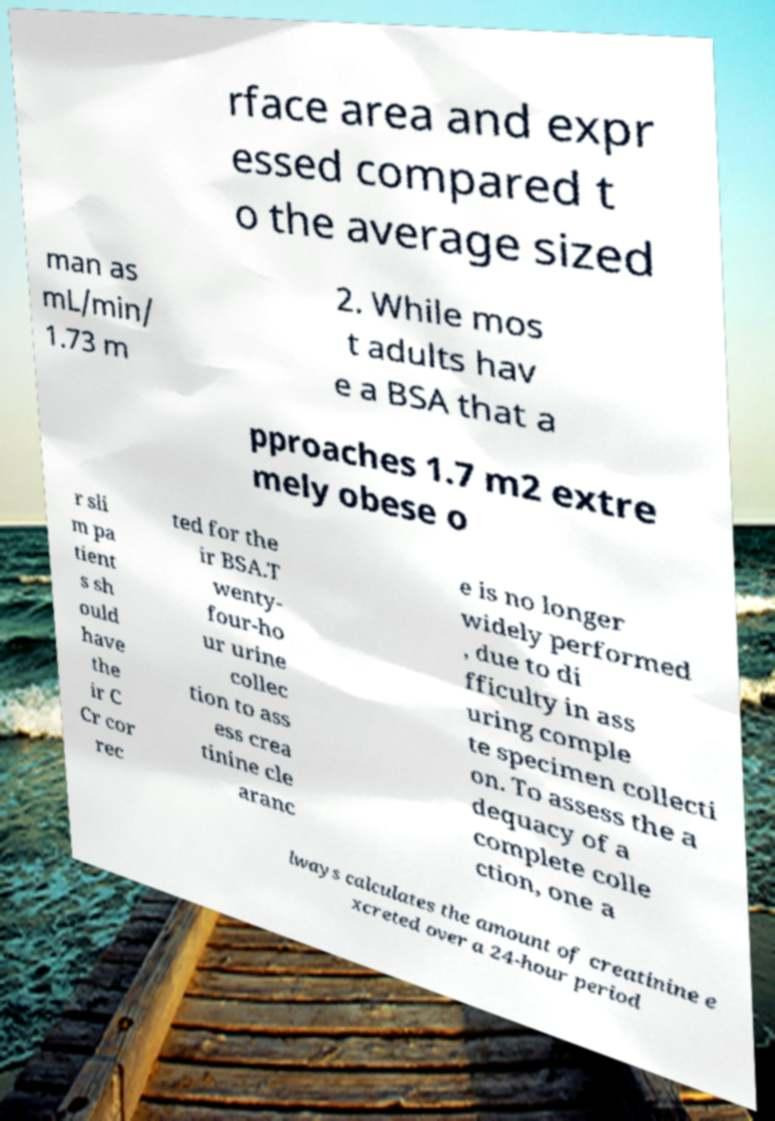There's text embedded in this image that I need extracted. Can you transcribe it verbatim? rface area and expr essed compared t o the average sized man as mL/min/ 1.73 m 2. While mos t adults hav e a BSA that a pproaches 1.7 m2 extre mely obese o r sli m pa tient s sh ould have the ir C Cr cor rec ted for the ir BSA.T wenty- four-ho ur urine collec tion to ass ess crea tinine cle aranc e is no longer widely performed , due to di fficulty in ass uring comple te specimen collecti on. To assess the a dequacy of a complete colle ction, one a lways calculates the amount of creatinine e xcreted over a 24-hour period 